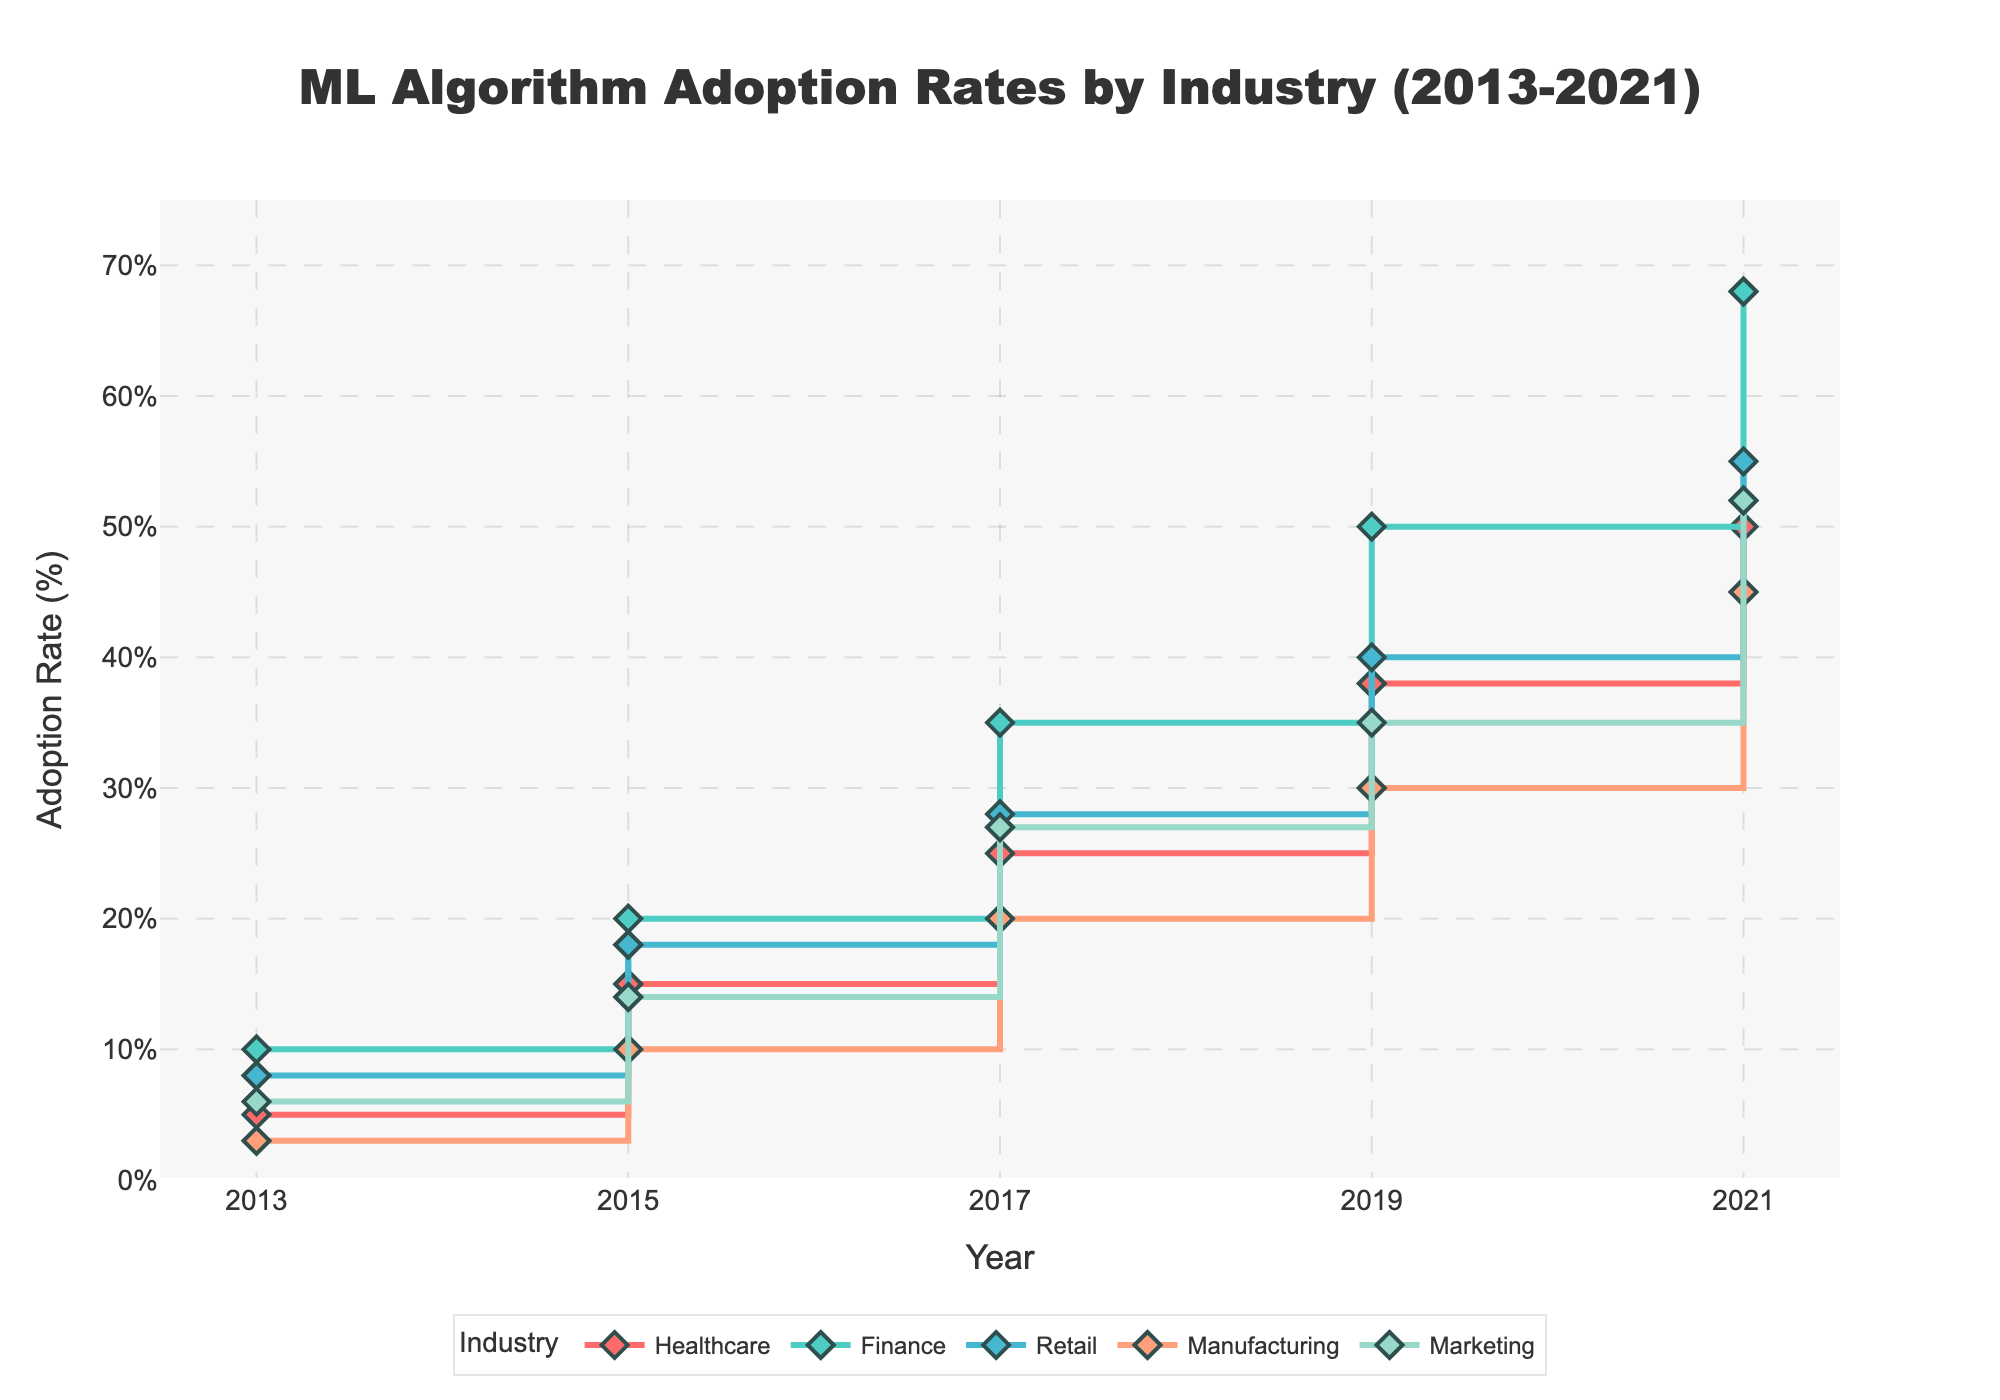What is the adoption rate of ML algorithms in the Finance industry in 2017? Look at the 2017 data point for the Finance industry plot, which is represented as a line with diamonds. The Y-axis value corresponding to 2017 is 35.
Answer: 35% Which industry had the highest adoption rate in 2021? Compare the endpoints of all lines for the year 2021. The Finance industry has the highest point at 68.
Answer: Finance By how much did the adoption rate in the Healthcare industry increase from 2013 to 2021? Subtract the adoption rate in 2013 from the rate in 2021 for the Healthcare industry: 50 - 5.
Answer: 45% What is the average adoption rate of ML algorithms in the Marketing industry over the observed years? Sum the adoption rates for Marketing over all the years and divide by the number of years: (6 + 14 + 27 + 35 + 52) / 5 = 134 / 5.
Answer: 26.8% Which industry showed the most significant increase in ML adoption from 2015 to 2017? Calculate the difference in adoption rates between 2015 and 2017 for each industry. The Finance industry shows the highest increase: 35 - 20 = 15.
Answer: Finance How did the adoption rate in the Manufacturing industry change from 2017 to 2019? The adoption rate for Manufacturing in 2017 is 20 and in 2019 is 30. Subtract the earlier rate from the latter: 30 - 20.
Answer: 10% Which year saw the largest overall increase in ML adoption rates across all industries? Calculate the adoption rate differences for each industry between consecutive years and find the year with the largest sum of differences. 2017 to 2019 shows the highest total increase.
Answer: 2017-2019 What was the difference in adoption rates between Healthcare and Retail in 2019? Look at the adoption rates for Healthcare and Retail in 2019 and subtract: 40 - 38.
Answer: 2% Which industry had the smallest adoption rate increase between 2013 and 2015? Calculate the difference in adoption rates between 2013 and 2015 for each industry. Manufacturing shows the smallest increase: 10 - 3 = 7.
Answer: Manufacturing What is the overall trend observed in the adoption rates of ML algorithms over the given period? All industries show an upward trend in the adoption rates from 2013 to 2021, indicating increasing acceptance of ML algorithms over the years.
Answer: Increasing trend 